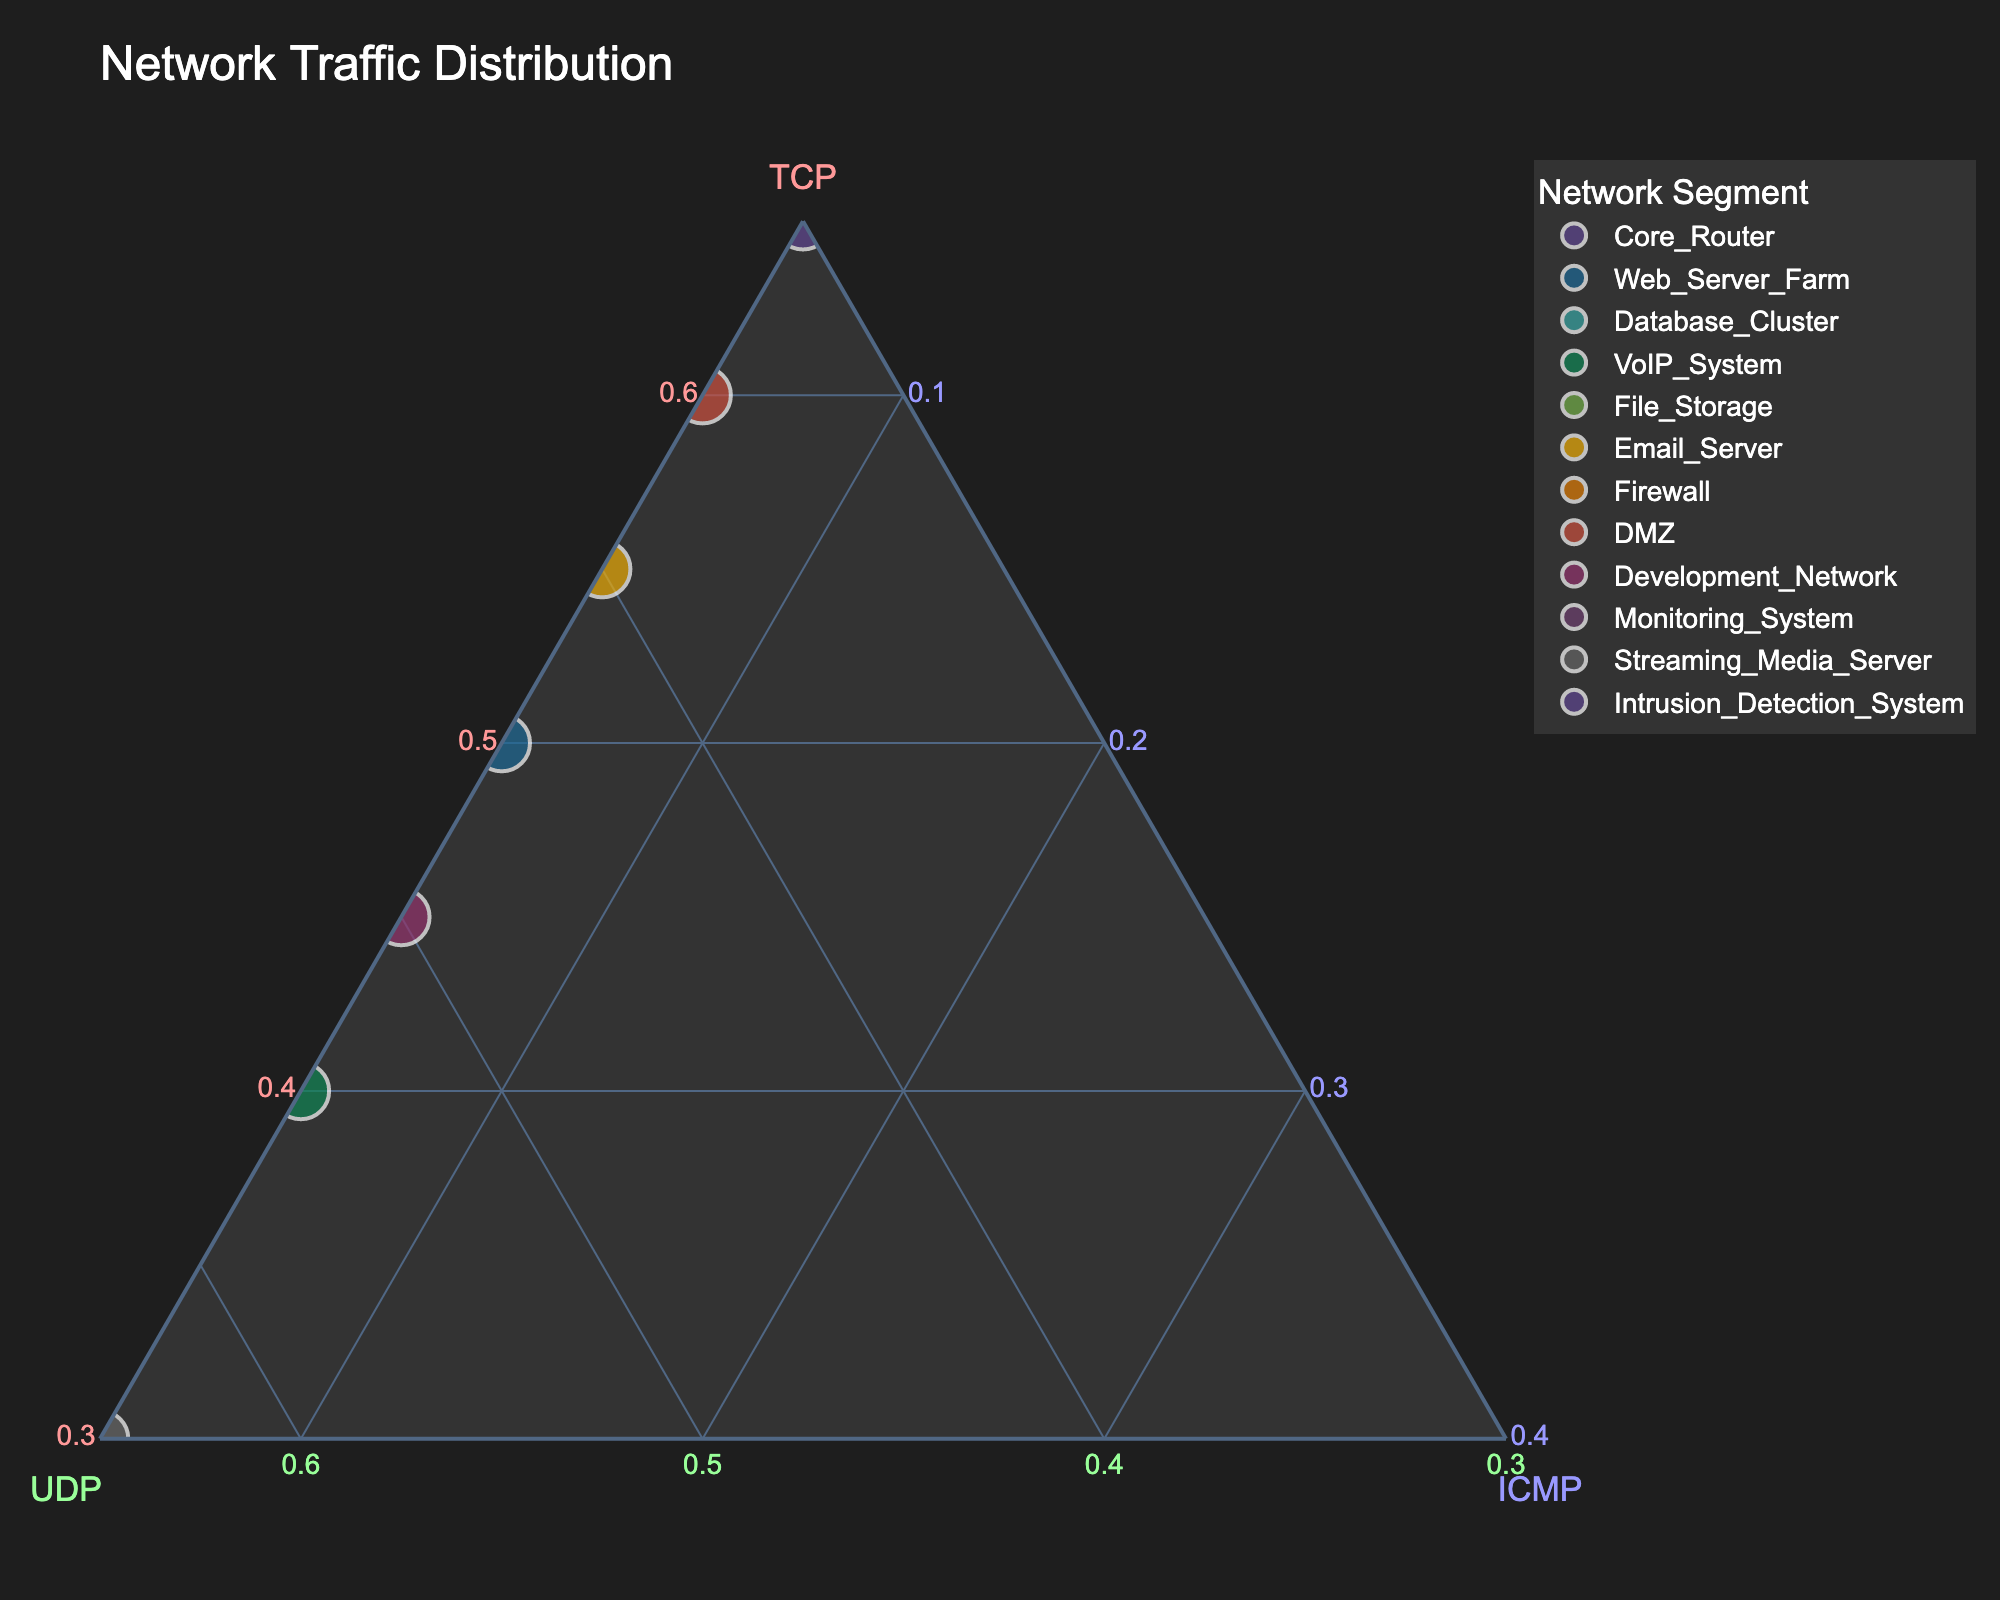What is the title of the plot? The plot's title is usually displayed at the top of a chart. In this figure, the title summarily describes the content.
Answer: Network Traffic Distribution How many network segments are represented in the plot? Count the unique data points or markers on the figure. Each point represents a different network segment.
Answer: 12 Which network segment has the highest TCP usage? Identify the point that is closest to the TCP vertex (top vertex) in the ternary plot.
Answer: Intrusion_Detection_System What is the distribution of network traffic for the Web Server Farm segment? Locate the Web Server Farm on the plot and check the values for TCP, UDP, and ICMP for this segment (referenced by hover text or axis positioning).
Answer: TCP: 50%, UDP: 45%, ICMP: 5% Which network segment has the highest UDP traffic? Identify the point that is closest to the UDP vertex (bottom left vertex) in the ternary plot.
Answer: Streaming_Media_Server Is there any network segment with equal proportions of TCP and UDP traffic? Compare the labels or positions of the points, looking for cases where the TCP and UDP values are the same or very close.
Answer: No Compare the TCP traffic of the Email Server and DMZ. Which one has a higher value, and by how much? Check the positioning of Email_Server and DMZ on the ternary plot, particularly their distances from the TCP vertex. Email_Server is 55%, DMZ is 60%. Calculate the difference.
Answer: DMZ has higher TCP by 5% What percentage of traffic is ICMP for all network segments? Since the ICMP traffic is the same across all segments, you can quickly check any point's distance from the ICMP vertex.
Answer: 5% Which network segment shows the most balanced distribution of TCP and UDP? Look for the point that is equidistant or nearly equidistant from the TCP and UDP vertices and also farther from ICMP vertex.
Answer: Web_Server_Farm Between Database_Cluster and Firewall, which segment has a lower UDP traffic? Compare the distances of Database_Cluster and Firewall from UDP vertex, Database_Cluster is 15%, Firewall is 20%.
Answer: Database_Cluster has lower UDP traffic What is the median value of TCP percentages across all network segments? List the TCP percentages, order them, and find the middle value. Values: 30, 40, 45, 50, 55, 60, 65, 70, 75, 80, 85, 90. Middle values are 60, 65. Average them: (60+65)/2 = 62.5.
Answer: 62.5% 